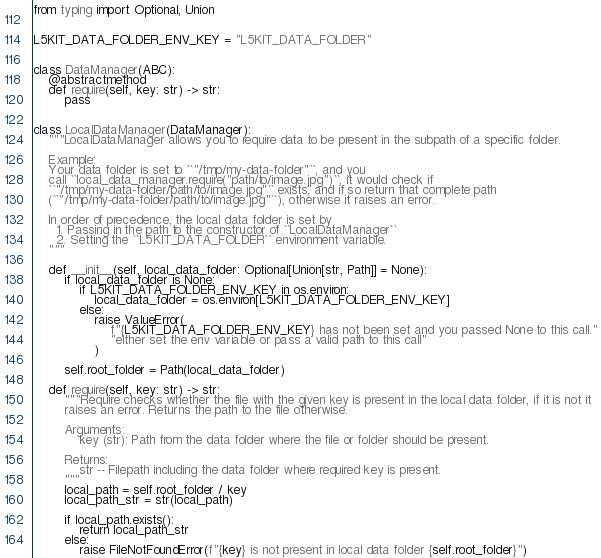<code> <loc_0><loc_0><loc_500><loc_500><_Python_>from typing import Optional, Union


L5KIT_DATA_FOLDER_ENV_KEY = "L5KIT_DATA_FOLDER"


class DataManager(ABC):
    @abstractmethod
    def require(self, key: str) -> str:
        pass


class LocalDataManager(DataManager):
    """LocalDataManager allows you to require data to be present in the subpath of a specific folder.

    Example:
    Your data folder is set to ``"/tmp/my-data-folder"``, and you
    call ``local_data_manager.require("path/to/image.jpg")``, it would check if
    ``"/tmp/my-data-folder/path/to/image.jpg"`` exists, and if so return that complete path
    (``"/tmp/my-data-folder/path/to/image.jpg"``), otherwise it raises an error.

    In order of precedence, the local data folder is set by
      1. Passing in the path to the constructor of ``LocalDataManager``
      2. Setting the ``L5KIT_DATA_FOLDER`` environment variable.
    """

    def __init__(self, local_data_folder: Optional[Union[str, Path]] = None):
        if local_data_folder is None:
            if L5KIT_DATA_FOLDER_ENV_KEY in os.environ:
                local_data_folder = os.environ[L5KIT_DATA_FOLDER_ENV_KEY]
            else:
                raise ValueError(
                    f"{L5KIT_DATA_FOLDER_ENV_KEY} has not been set and you passed None to this call."
                    "either set the env variable or pass a valid path to this call"
                )

        self.root_folder = Path(local_data_folder)

    def require(self, key: str) -> str:
        """Require checks whether the file with the given key is present in the local data folder, if it is not it
        raises an error. Returns the path to the file otherwise.

        Arguments:
            key (str): Path from the data folder where the file or folder should be present.

        Returns:
            str -- Filepath including the data folder where required key is present.
        """
        local_path = self.root_folder / key
        local_path_str = str(local_path)

        if local_path.exists():
            return local_path_str
        else:
            raise FileNotFoundError(f"{key} is not present in local data folder {self.root_folder}")
</code> 